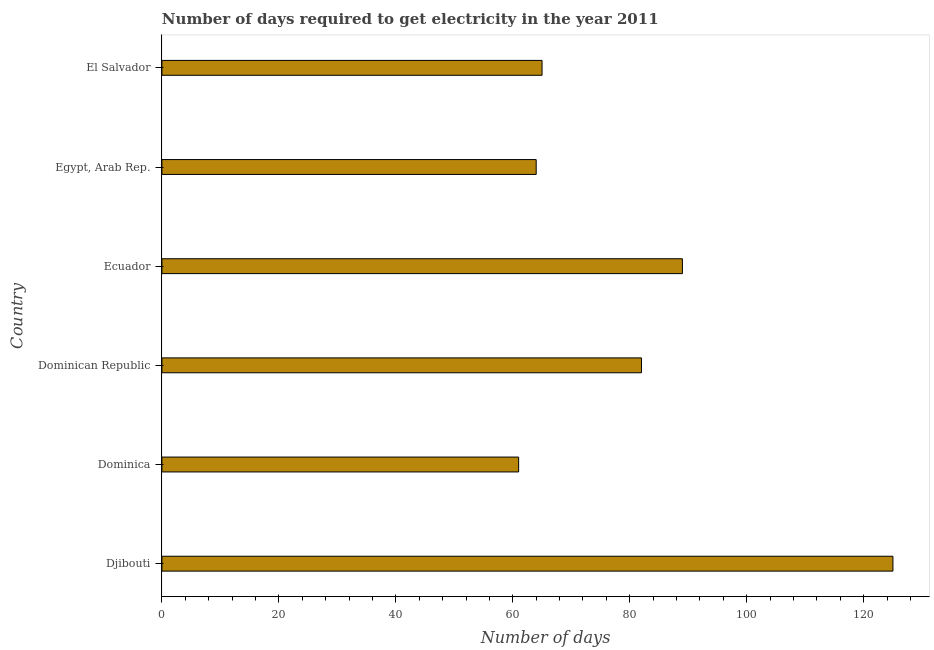What is the title of the graph?
Your answer should be very brief. Number of days required to get electricity in the year 2011. What is the label or title of the X-axis?
Ensure brevity in your answer.  Number of days. What is the time to get electricity in Ecuador?
Give a very brief answer. 89. Across all countries, what is the maximum time to get electricity?
Give a very brief answer. 125. In which country was the time to get electricity maximum?
Your answer should be compact. Djibouti. In which country was the time to get electricity minimum?
Offer a very short reply. Dominica. What is the sum of the time to get electricity?
Provide a short and direct response. 486. What is the difference between the time to get electricity in Dominican Republic and Ecuador?
Provide a succinct answer. -7. What is the average time to get electricity per country?
Offer a very short reply. 81. What is the median time to get electricity?
Make the answer very short. 73.5. What is the ratio of the time to get electricity in Egypt, Arab Rep. to that in El Salvador?
Provide a succinct answer. 0.98. What is the difference between the highest and the second highest time to get electricity?
Give a very brief answer. 36. Is the sum of the time to get electricity in Djibouti and Egypt, Arab Rep. greater than the maximum time to get electricity across all countries?
Keep it short and to the point. Yes. In how many countries, is the time to get electricity greater than the average time to get electricity taken over all countries?
Give a very brief answer. 3. Are all the bars in the graph horizontal?
Provide a short and direct response. Yes. What is the difference between two consecutive major ticks on the X-axis?
Give a very brief answer. 20. What is the Number of days in Djibouti?
Give a very brief answer. 125. What is the Number of days of Dominica?
Offer a very short reply. 61. What is the Number of days of Dominican Republic?
Provide a succinct answer. 82. What is the Number of days of Ecuador?
Make the answer very short. 89. What is the difference between the Number of days in Djibouti and Dominican Republic?
Your answer should be very brief. 43. What is the difference between the Number of days in Djibouti and El Salvador?
Make the answer very short. 60. What is the difference between the Number of days in Dominica and Egypt, Arab Rep.?
Give a very brief answer. -3. What is the difference between the Number of days in Dominican Republic and Ecuador?
Provide a short and direct response. -7. What is the difference between the Number of days in Dominican Republic and Egypt, Arab Rep.?
Offer a very short reply. 18. What is the difference between the Number of days in Dominican Republic and El Salvador?
Your answer should be compact. 17. What is the difference between the Number of days in Ecuador and Egypt, Arab Rep.?
Your answer should be very brief. 25. What is the difference between the Number of days in Ecuador and El Salvador?
Give a very brief answer. 24. What is the ratio of the Number of days in Djibouti to that in Dominica?
Provide a short and direct response. 2.05. What is the ratio of the Number of days in Djibouti to that in Dominican Republic?
Give a very brief answer. 1.52. What is the ratio of the Number of days in Djibouti to that in Ecuador?
Provide a succinct answer. 1.4. What is the ratio of the Number of days in Djibouti to that in Egypt, Arab Rep.?
Your answer should be very brief. 1.95. What is the ratio of the Number of days in Djibouti to that in El Salvador?
Your answer should be very brief. 1.92. What is the ratio of the Number of days in Dominica to that in Dominican Republic?
Provide a succinct answer. 0.74. What is the ratio of the Number of days in Dominica to that in Ecuador?
Provide a succinct answer. 0.69. What is the ratio of the Number of days in Dominica to that in Egypt, Arab Rep.?
Offer a very short reply. 0.95. What is the ratio of the Number of days in Dominica to that in El Salvador?
Your answer should be very brief. 0.94. What is the ratio of the Number of days in Dominican Republic to that in Ecuador?
Offer a very short reply. 0.92. What is the ratio of the Number of days in Dominican Republic to that in Egypt, Arab Rep.?
Ensure brevity in your answer.  1.28. What is the ratio of the Number of days in Dominican Republic to that in El Salvador?
Provide a succinct answer. 1.26. What is the ratio of the Number of days in Ecuador to that in Egypt, Arab Rep.?
Your answer should be very brief. 1.39. What is the ratio of the Number of days in Ecuador to that in El Salvador?
Your response must be concise. 1.37. What is the ratio of the Number of days in Egypt, Arab Rep. to that in El Salvador?
Give a very brief answer. 0.98. 